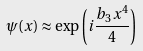Convert formula to latex. <formula><loc_0><loc_0><loc_500><loc_500>\psi ( x ) \approx \exp \left ( i \frac { b _ { 3 } x ^ { 4 } } { 4 } \right )</formula> 